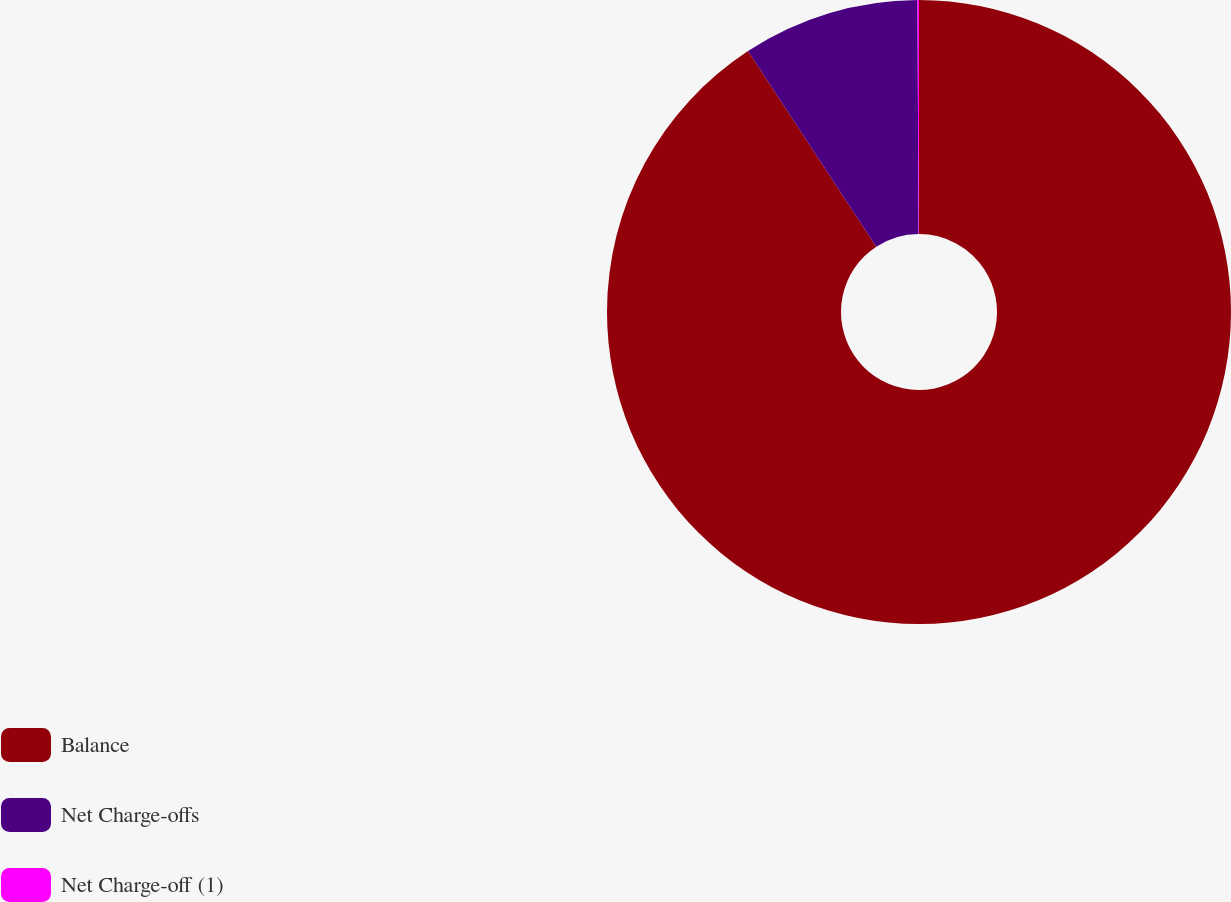<chart> <loc_0><loc_0><loc_500><loc_500><pie_chart><fcel>Balance<fcel>Net Charge-offs<fcel>Net Charge-off (1)<nl><fcel>90.77%<fcel>9.15%<fcel>0.08%<nl></chart> 